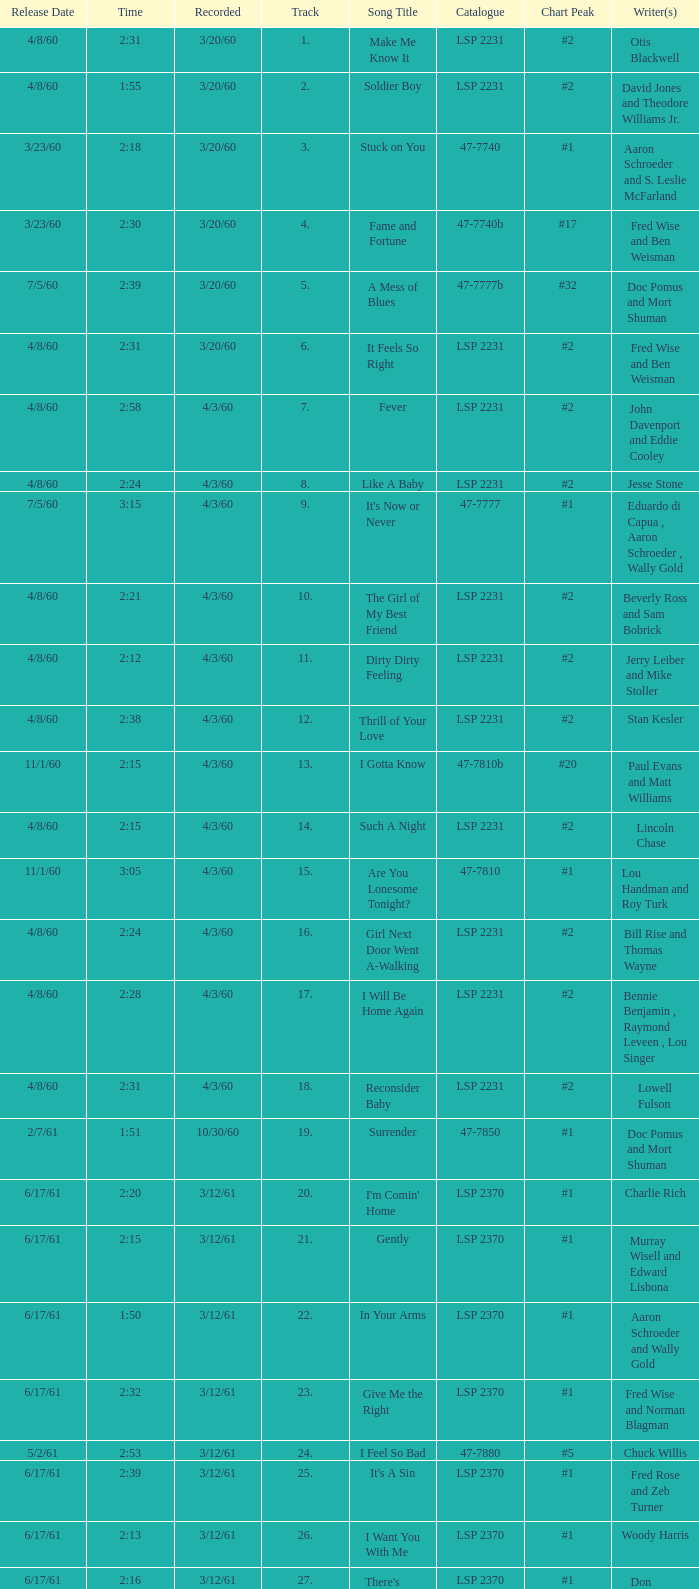On songs that have a release date of 6/17/61, a track larger than 20, and a writer of Woody Harris, what is the chart peak? #1. 